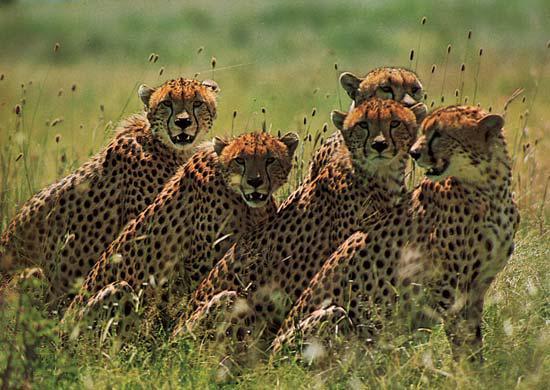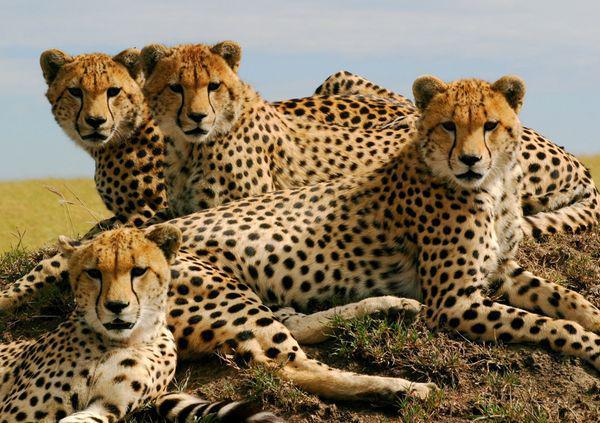The first image is the image on the left, the second image is the image on the right. Analyze the images presented: Is the assertion "The left image contains more cheetahs than the right image." valid? Answer yes or no. Yes. The first image is the image on the left, the second image is the image on the right. Given the left and right images, does the statement "In the leftmost image there are exactly five cheetahs sitting down." hold true? Answer yes or no. Yes. 